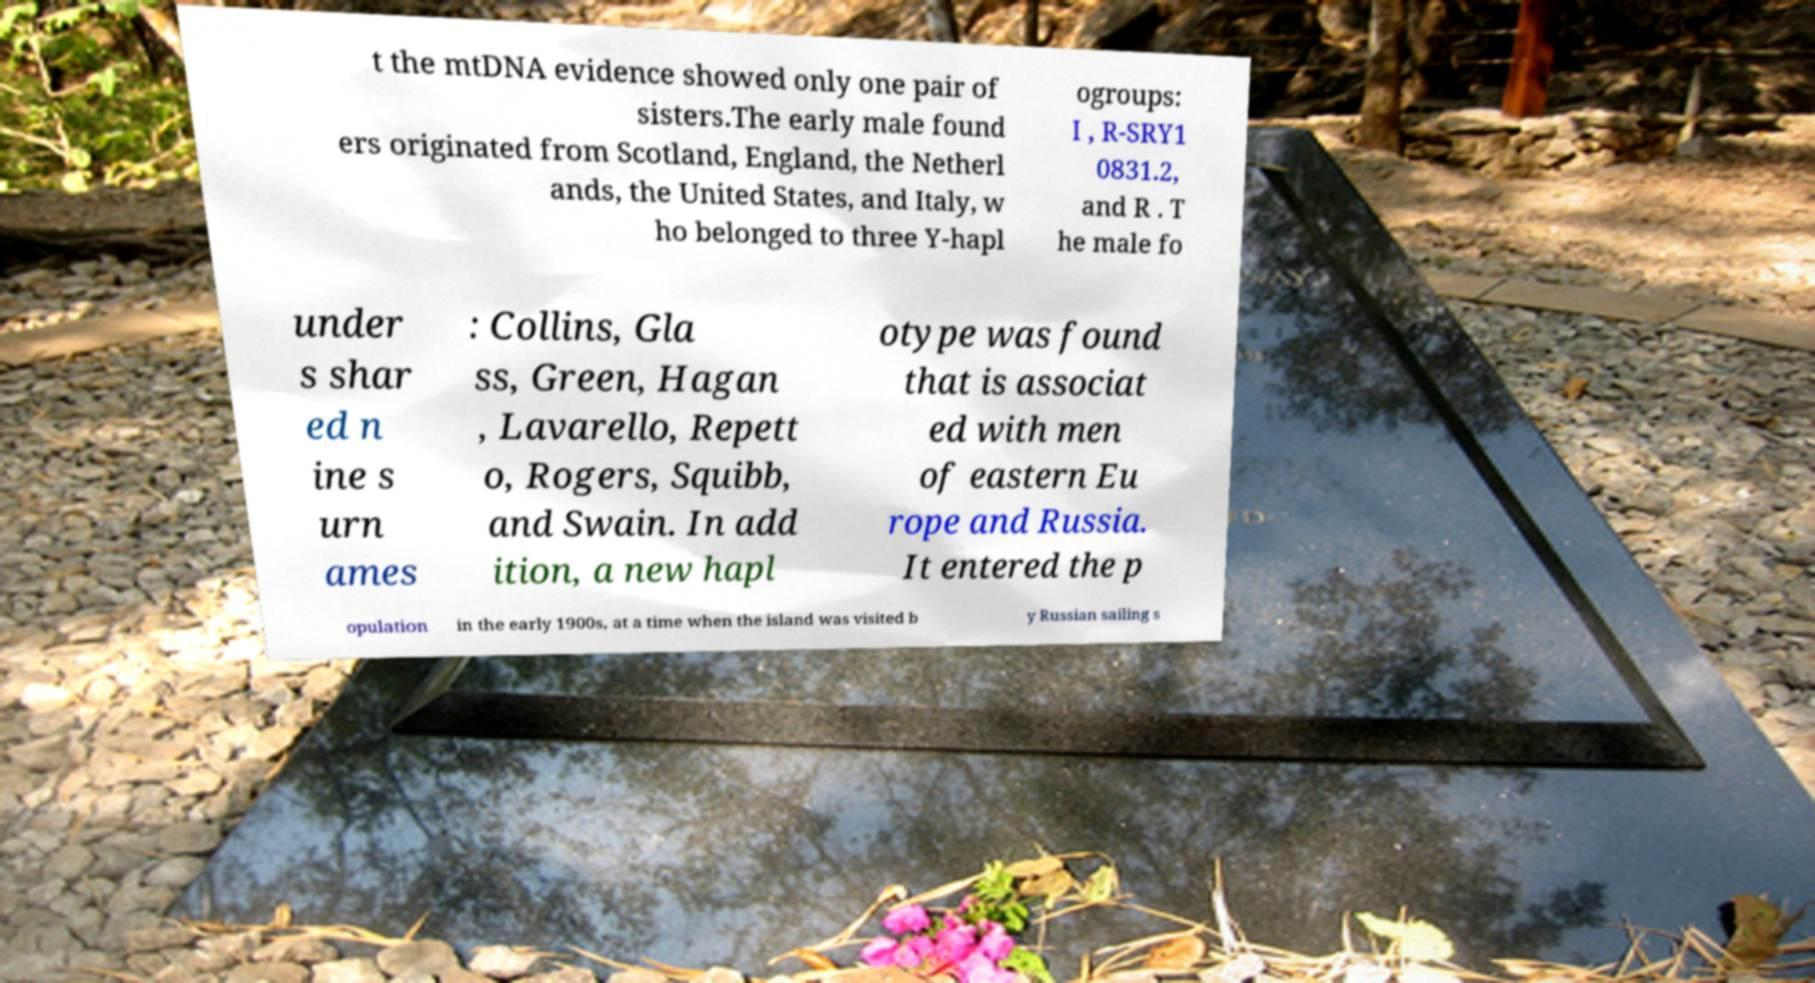Can you accurately transcribe the text from the provided image for me? t the mtDNA evidence showed only one pair of sisters.The early male found ers originated from Scotland, England, the Netherl ands, the United States, and Italy, w ho belonged to three Y-hapl ogroups: I , R-SRY1 0831.2, and R . T he male fo under s shar ed n ine s urn ames : Collins, Gla ss, Green, Hagan , Lavarello, Repett o, Rogers, Squibb, and Swain. In add ition, a new hapl otype was found that is associat ed with men of eastern Eu rope and Russia. It entered the p opulation in the early 1900s, at a time when the island was visited b y Russian sailing s 